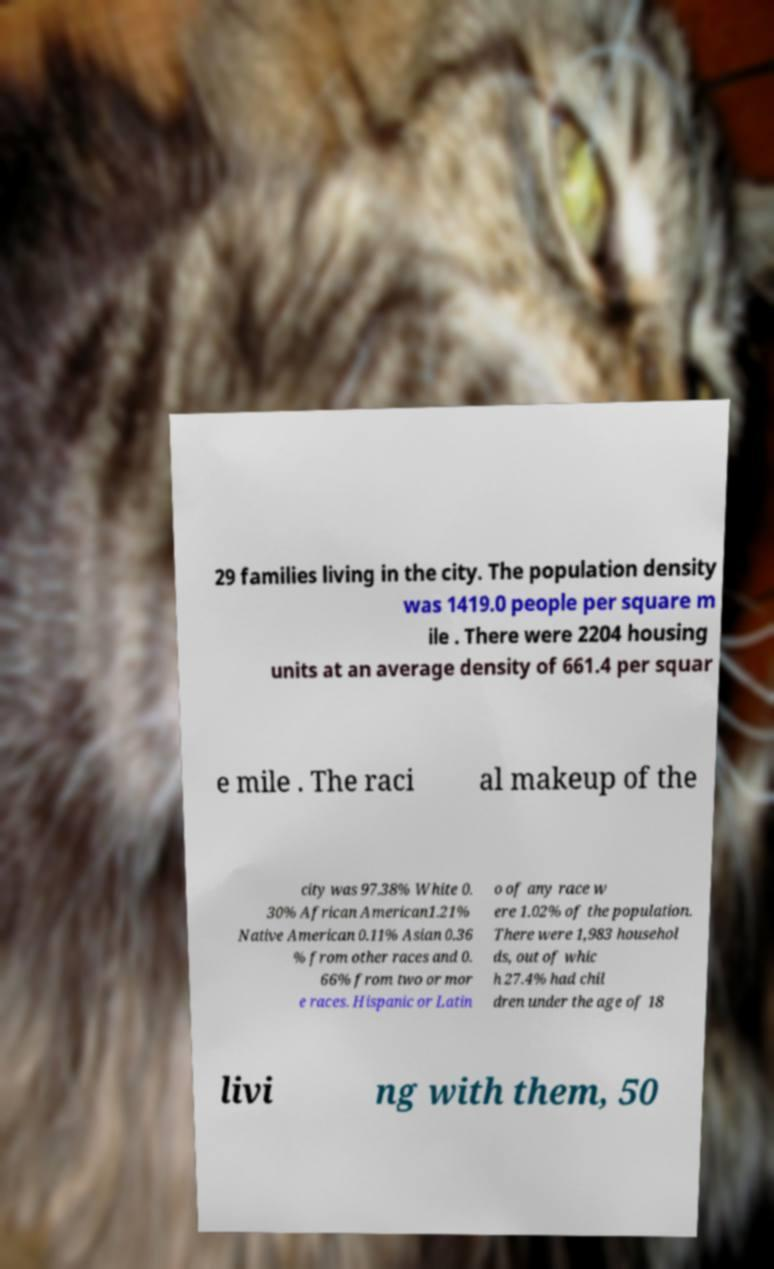Could you assist in decoding the text presented in this image and type it out clearly? 29 families living in the city. The population density was 1419.0 people per square m ile . There were 2204 housing units at an average density of 661.4 per squar e mile . The raci al makeup of the city was 97.38% White 0. 30% African American1.21% Native American 0.11% Asian 0.36 % from other races and 0. 66% from two or mor e races. Hispanic or Latin o of any race w ere 1.02% of the population. There were 1,983 househol ds, out of whic h 27.4% had chil dren under the age of 18 livi ng with them, 50 